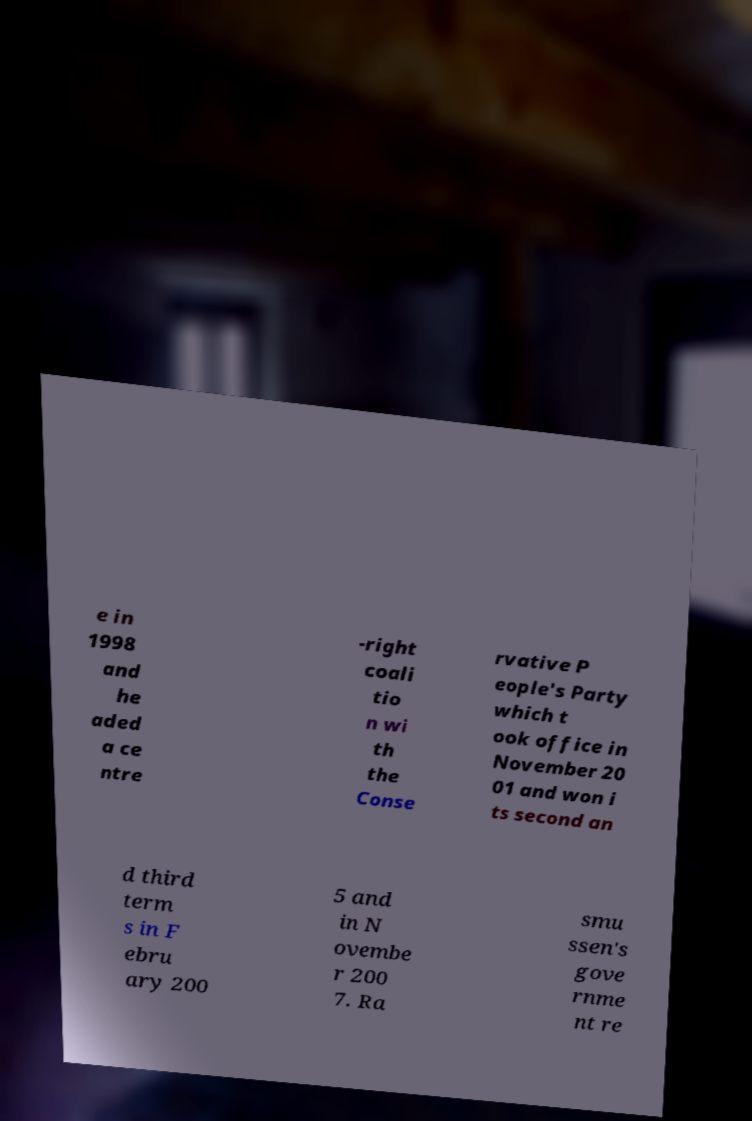Can you accurately transcribe the text from the provided image for me? e in 1998 and he aded a ce ntre -right coali tio n wi th the Conse rvative P eople's Party which t ook office in November 20 01 and won i ts second an d third term s in F ebru ary 200 5 and in N ovembe r 200 7. Ra smu ssen's gove rnme nt re 